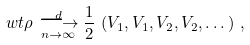<formula> <loc_0><loc_0><loc_500><loc_500>\ w t \rho \overset { d } { \underset { n \to \infty } { \longrightarrow } } \frac { 1 } { 2 } \, \left ( V _ { 1 } , V _ { 1 } , V _ { 2 } , V _ { 2 } , \dots \right ) \, ,</formula> 